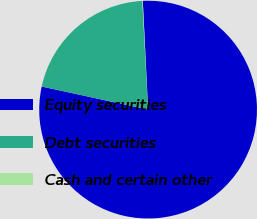Convert chart to OTSL. <chart><loc_0><loc_0><loc_500><loc_500><pie_chart><fcel>Equity securities<fcel>Debt securities<fcel>Cash and certain other<nl><fcel>79.18%<fcel>20.75%<fcel>0.07%<nl></chart> 